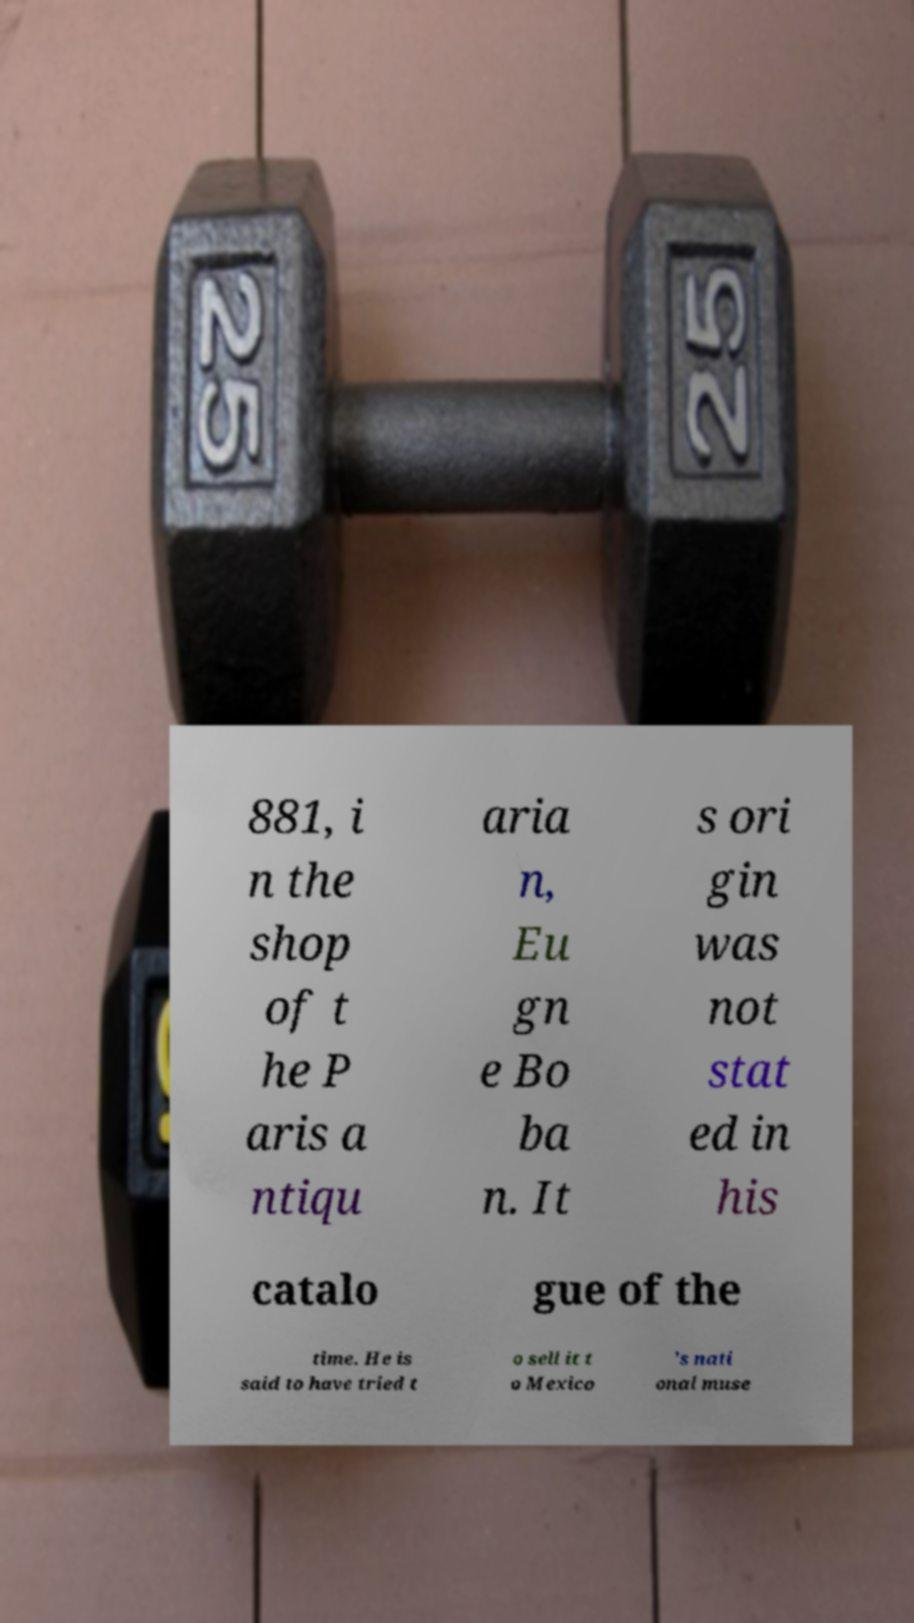Could you extract and type out the text from this image? 881, i n the shop of t he P aris a ntiqu aria n, Eu gn e Bo ba n. It s ori gin was not stat ed in his catalo gue of the time. He is said to have tried t o sell it t o Mexico 's nati onal muse 